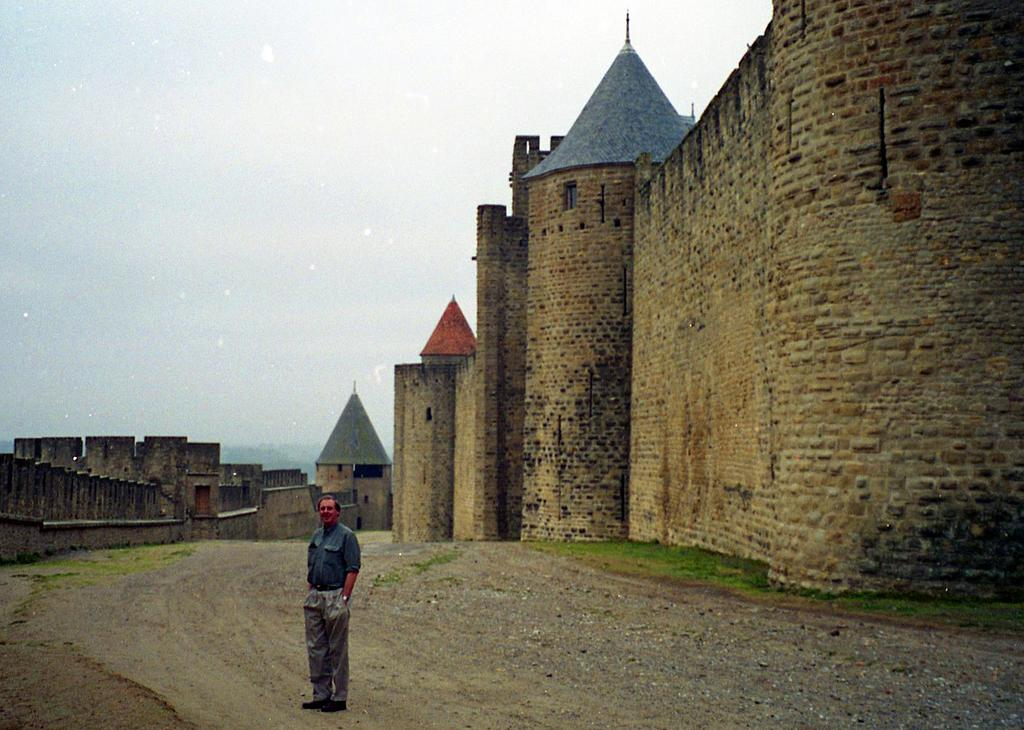What is the person in the image doing? There is a person standing on the pathway in the image. What type of surface can be seen under the person's feet? There are stones visible in the image. What type of vegetation is present in the image? There is grass in the image. What type of structures can be seen in the image? There are buildings and walls present in the image. What is visible in the sky in the image? The sky is visible in the image, and it looks cloudy. What type of jail can be seen in the image? There is no jail present in the image. What kind of offer is the person making in the image? There is no indication of any offer being made in the image. 